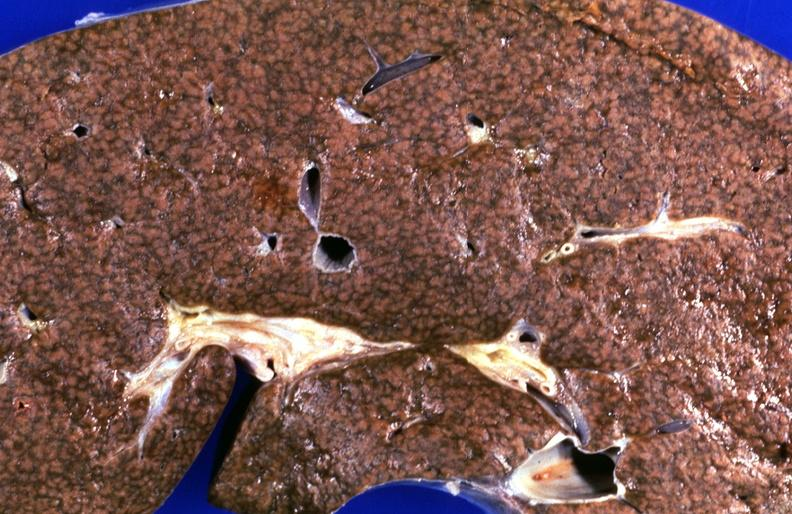does stomach show kidney, hemochromatosis?
Answer the question using a single word or phrase. No 